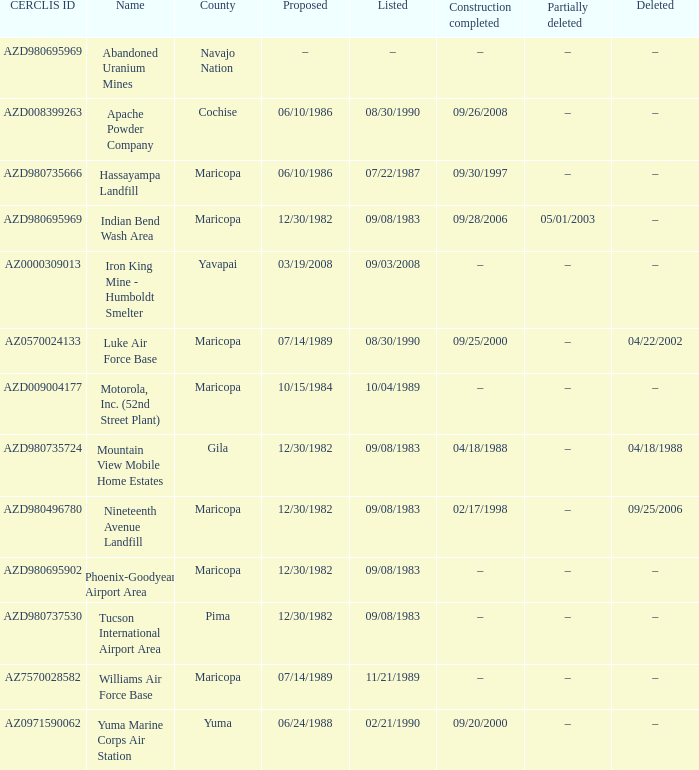What is the cerclis id when the site was recommended on 12/30/1982 and was partly eliminated on 05/01/2003? AZD980695969. Can you parse all the data within this table? {'header': ['CERCLIS ID', 'Name', 'County', 'Proposed', 'Listed', 'Construction completed', 'Partially deleted', 'Deleted'], 'rows': [['AZD980695969', 'Abandoned Uranium Mines', 'Navajo Nation', '–', '–', '–', '–', '–'], ['AZD008399263', 'Apache Powder Company', 'Cochise', '06/10/1986', '08/30/1990', '09/26/2008', '–', '–'], ['AZD980735666', 'Hassayampa Landfill', 'Maricopa', '06/10/1986', '07/22/1987', '09/30/1997', '–', '–'], ['AZD980695969', 'Indian Bend Wash Area', 'Maricopa', '12/30/1982', '09/08/1983', '09/28/2006', '05/01/2003', '–'], ['AZ0000309013', 'Iron King Mine - Humboldt Smelter', 'Yavapai', '03/19/2008', '09/03/2008', '–', '–', '–'], ['AZ0570024133', 'Luke Air Force Base', 'Maricopa', '07/14/1989', '08/30/1990', '09/25/2000', '–', '04/22/2002'], ['AZD009004177', 'Motorola, Inc. (52nd Street Plant)', 'Maricopa', '10/15/1984', '10/04/1989', '–', '–', '–'], ['AZD980735724', 'Mountain View Mobile Home Estates', 'Gila', '12/30/1982', '09/08/1983', '04/18/1988', '–', '04/18/1988'], ['AZD980496780', 'Nineteenth Avenue Landfill', 'Maricopa', '12/30/1982', '09/08/1983', '02/17/1998', '–', '09/25/2006'], ['AZD980695902', 'Phoenix-Goodyear Airport Area', 'Maricopa', '12/30/1982', '09/08/1983', '–', '–', '–'], ['AZD980737530', 'Tucson International Airport Area', 'Pima', '12/30/1982', '09/08/1983', '–', '–', '–'], ['AZ7570028582', 'Williams Air Force Base', 'Maricopa', '07/14/1989', '11/21/1989', '–', '–', '–'], ['AZ0971590062', 'Yuma Marine Corps Air Station', 'Yuma', '06/24/1988', '02/21/1990', '09/20/2000', '–', '–']]} 